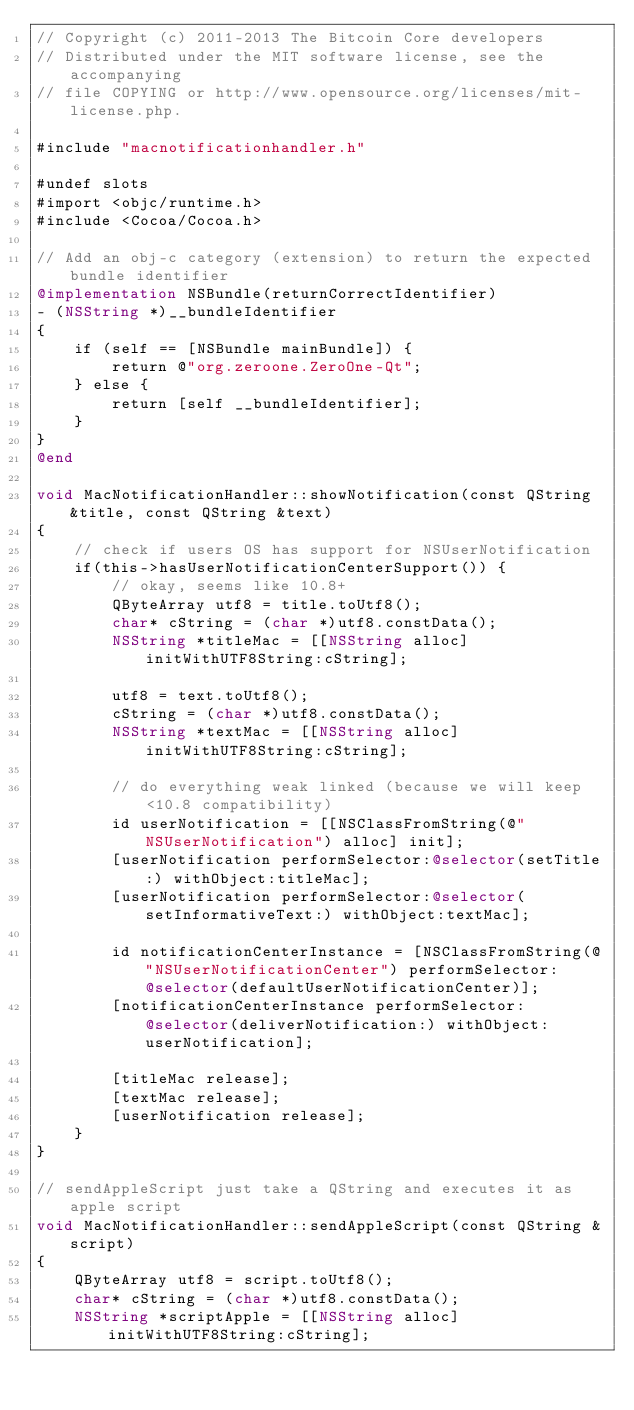Convert code to text. <code><loc_0><loc_0><loc_500><loc_500><_ObjectiveC_>// Copyright (c) 2011-2013 The Bitcoin Core developers
// Distributed under the MIT software license, see the accompanying
// file COPYING or http://www.opensource.org/licenses/mit-license.php.

#include "macnotificationhandler.h"

#undef slots
#import <objc/runtime.h>
#include <Cocoa/Cocoa.h>

// Add an obj-c category (extension) to return the expected bundle identifier
@implementation NSBundle(returnCorrectIdentifier)
- (NSString *)__bundleIdentifier
{
    if (self == [NSBundle mainBundle]) {
        return @"org.zeroone.ZeroOne-Qt";
    } else {
        return [self __bundleIdentifier];
    }
}
@end

void MacNotificationHandler::showNotification(const QString &title, const QString &text)
{
    // check if users OS has support for NSUserNotification
    if(this->hasUserNotificationCenterSupport()) {
        // okay, seems like 10.8+
        QByteArray utf8 = title.toUtf8();
        char* cString = (char *)utf8.constData();
        NSString *titleMac = [[NSString alloc] initWithUTF8String:cString];

        utf8 = text.toUtf8();
        cString = (char *)utf8.constData();
        NSString *textMac = [[NSString alloc] initWithUTF8String:cString];

        // do everything weak linked (because we will keep <10.8 compatibility)
        id userNotification = [[NSClassFromString(@"NSUserNotification") alloc] init];
        [userNotification performSelector:@selector(setTitle:) withObject:titleMac];
        [userNotification performSelector:@selector(setInformativeText:) withObject:textMac];

        id notificationCenterInstance = [NSClassFromString(@"NSUserNotificationCenter") performSelector:@selector(defaultUserNotificationCenter)];
        [notificationCenterInstance performSelector:@selector(deliverNotification:) withObject:userNotification];

        [titleMac release];
        [textMac release];
        [userNotification release];
    }
}

// sendAppleScript just take a QString and executes it as apple script
void MacNotificationHandler::sendAppleScript(const QString &script)
{
    QByteArray utf8 = script.toUtf8();
    char* cString = (char *)utf8.constData();
    NSString *scriptApple = [[NSString alloc] initWithUTF8String:cString];
</code> 